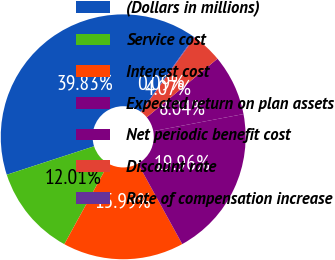Convert chart. <chart><loc_0><loc_0><loc_500><loc_500><pie_chart><fcel>(Dollars in millions)<fcel>Service cost<fcel>Interest cost<fcel>Expected return on plan assets<fcel>Net periodic benefit cost<fcel>Discount rate<fcel>Rate of compensation increase<nl><fcel>39.83%<fcel>12.01%<fcel>15.99%<fcel>19.96%<fcel>8.04%<fcel>4.07%<fcel>0.09%<nl></chart> 